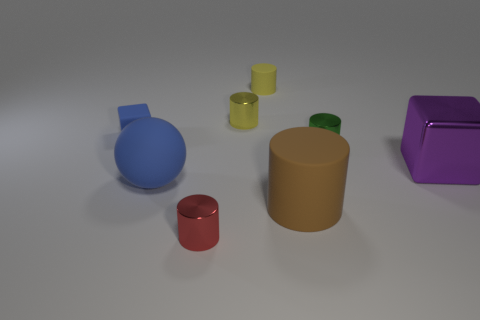Subtract all yellow cylinders. How many were subtracted if there are1yellow cylinders left? 1 Add 1 tiny blue objects. How many objects exist? 9 Subtract 0 green spheres. How many objects are left? 8 Subtract all balls. How many objects are left? 7 Subtract 1 cylinders. How many cylinders are left? 4 Subtract all yellow balls. Subtract all blue cylinders. How many balls are left? 1 Subtract all gray cylinders. How many blue blocks are left? 1 Subtract all big purple metal blocks. Subtract all big brown objects. How many objects are left? 6 Add 1 red cylinders. How many red cylinders are left? 2 Add 2 gray metallic objects. How many gray metallic objects exist? 2 